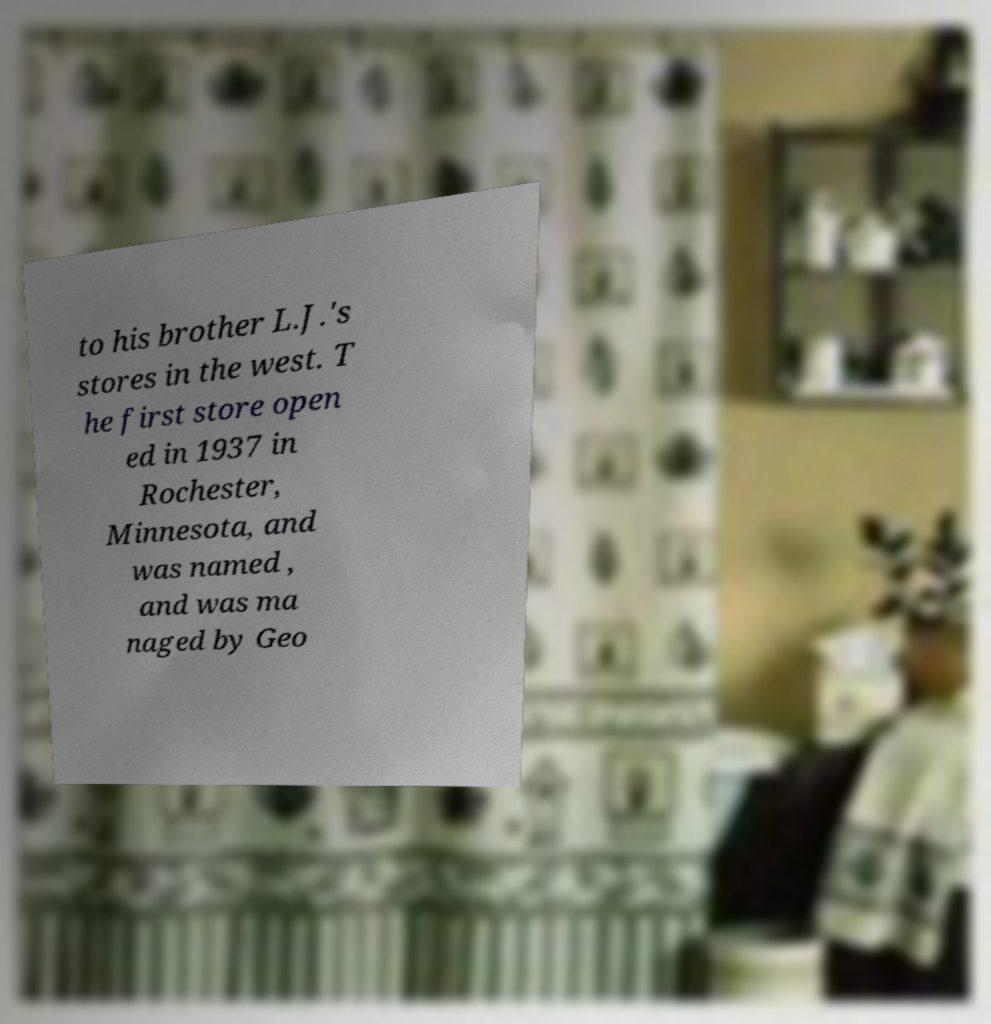For documentation purposes, I need the text within this image transcribed. Could you provide that? to his brother L.J.'s stores in the west. T he first store open ed in 1937 in Rochester, Minnesota, and was named , and was ma naged by Geo 